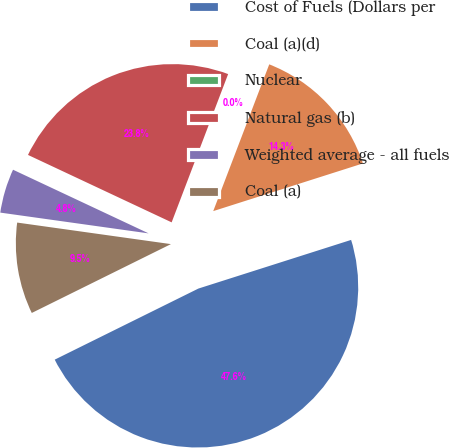Convert chart. <chart><loc_0><loc_0><loc_500><loc_500><pie_chart><fcel>Cost of Fuels (Dollars per<fcel>Coal (a)(d)<fcel>Nuclear<fcel>Natural gas (b)<fcel>Weighted average - all fuels<fcel>Coal (a)<nl><fcel>47.6%<fcel>14.29%<fcel>0.01%<fcel>23.81%<fcel>4.77%<fcel>9.53%<nl></chart> 